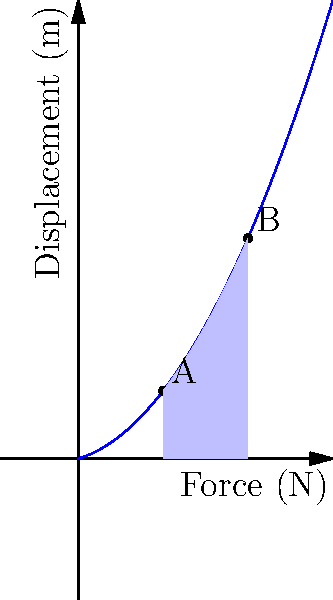In the graph above, which represents the force-displacement relationship in a typical Asian martial arts defensive technique, what does the shaded area between points A and B represent in terms of biomechanics? To understand what the shaded area represents, let's follow these steps:

1. The x-axis represents displacement (m), and the y-axis represents force (N).
2. The curve shows how the force changes with displacement during a defensive technique.
3. The shaded area is bounded by the curve from point A to point B, and the x-axis.
4. In physics and biomechanics, the area under a force-displacement curve represents work or energy.
5. Work is defined as force multiplied by displacement: $W = F \cdot d$
6. Mathematically, this is equivalent to the integral of force with respect to displacement:

   $$W = \int_{x_1}^{x_2} F(x) dx$$

7. The shaded area visually represents this integral.
8. In the context of martial arts, this work or energy represents the amount of energy absorbed or dissipated during the defensive technique.

Therefore, the shaded area represents the work done or energy absorbed/dissipated during the defensive technique between positions A and B.
Answer: Work done or energy absorbed/dissipated during the defensive technique 